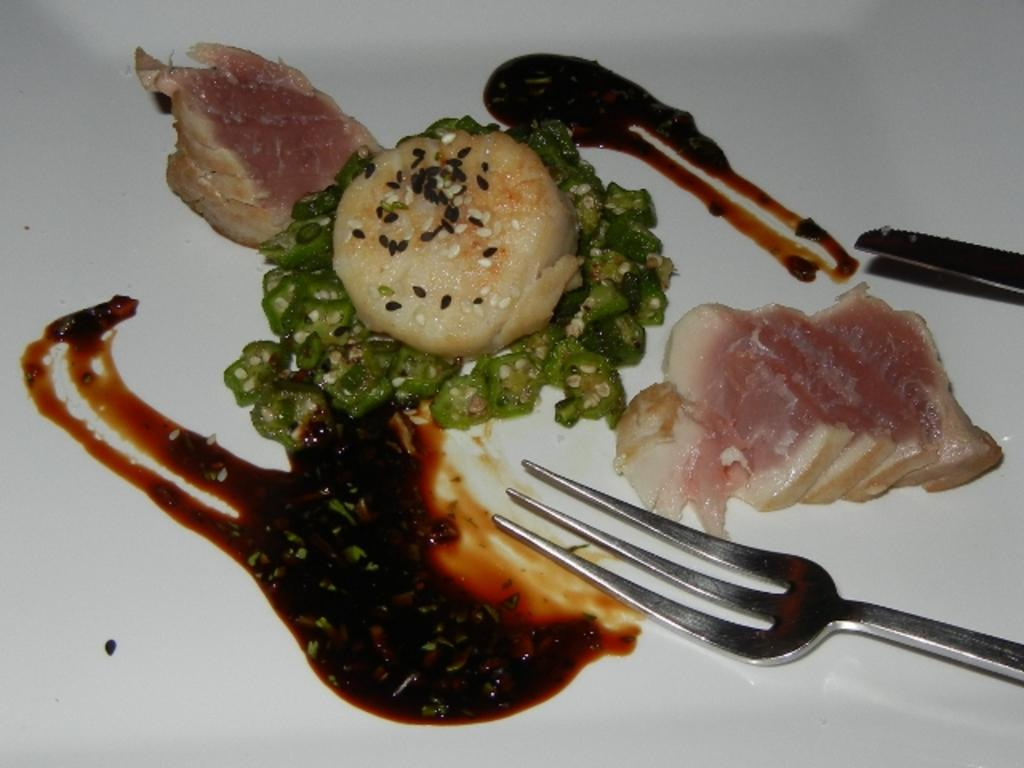What is the main subject of the image? The main subject of the image is food on a white surface. What utensil can be seen in the image? There is a fork visible in the image. What type of sand can be seen in the image? There is no sand present in the image; it features food on a white surface and a fork. What type of porter is serving the dinner in the image? There is no dinner or porter present in the image; it only shows food on a white surface and a fork. 